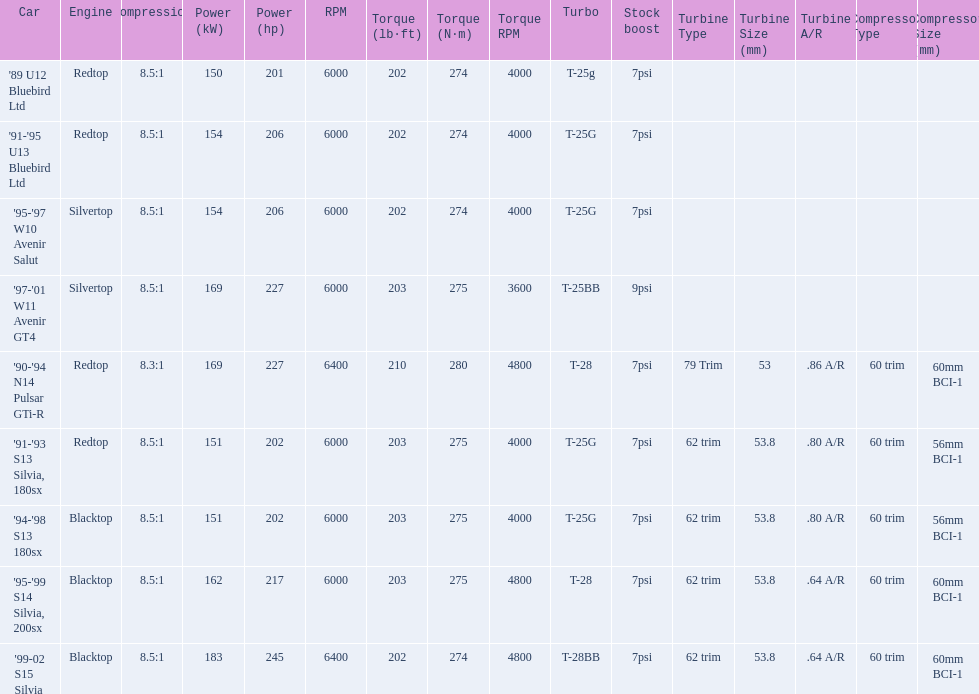Which cars featured blacktop engines? '94-'98 S13 180sx, '95-'99 S14 Silvia, 200sx, '99-02 S15 Silvia. Which of these had t-04b compressor housings? '95-'99 S14 Silvia, 200sx, '99-02 S15 Silvia. Which one of these has the highest horsepower? '99-02 S15 Silvia. 